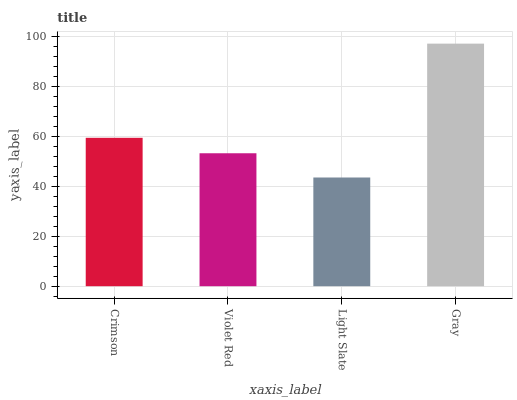Is Light Slate the minimum?
Answer yes or no. Yes. Is Gray the maximum?
Answer yes or no. Yes. Is Violet Red the minimum?
Answer yes or no. No. Is Violet Red the maximum?
Answer yes or no. No. Is Crimson greater than Violet Red?
Answer yes or no. Yes. Is Violet Red less than Crimson?
Answer yes or no. Yes. Is Violet Red greater than Crimson?
Answer yes or no. No. Is Crimson less than Violet Red?
Answer yes or no. No. Is Crimson the high median?
Answer yes or no. Yes. Is Violet Red the low median?
Answer yes or no. Yes. Is Light Slate the high median?
Answer yes or no. No. Is Gray the low median?
Answer yes or no. No. 